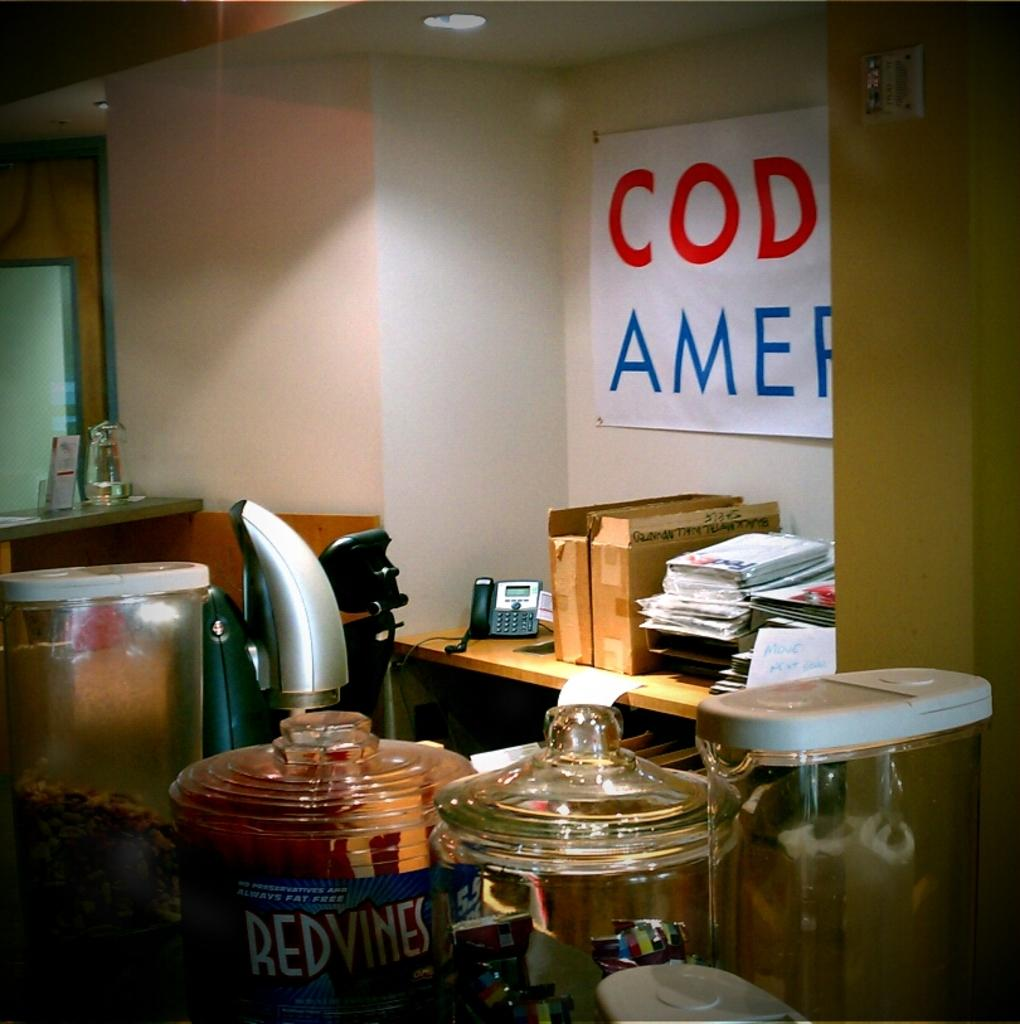<image>
Give a short and clear explanation of the subsequent image. Glass containers with one containing Red Vines in it. 